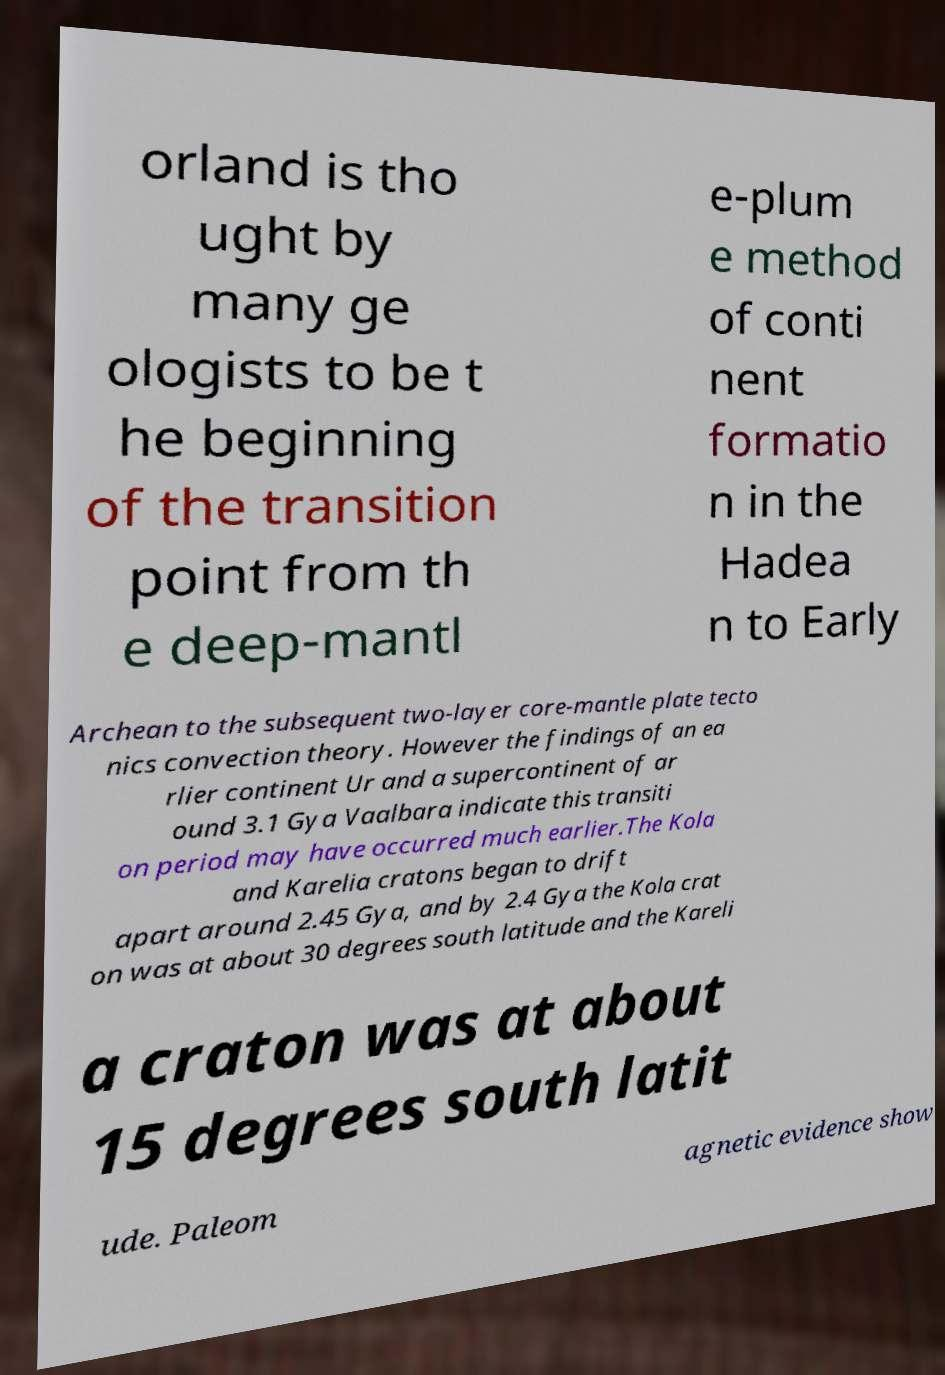Can you accurately transcribe the text from the provided image for me? orland is tho ught by many ge ologists to be t he beginning of the transition point from th e deep-mantl e-plum e method of conti nent formatio n in the Hadea n to Early Archean to the subsequent two-layer core-mantle plate tecto nics convection theory. However the findings of an ea rlier continent Ur and a supercontinent of ar ound 3.1 Gya Vaalbara indicate this transiti on period may have occurred much earlier.The Kola and Karelia cratons began to drift apart around 2.45 Gya, and by 2.4 Gya the Kola crat on was at about 30 degrees south latitude and the Kareli a craton was at about 15 degrees south latit ude. Paleom agnetic evidence show 